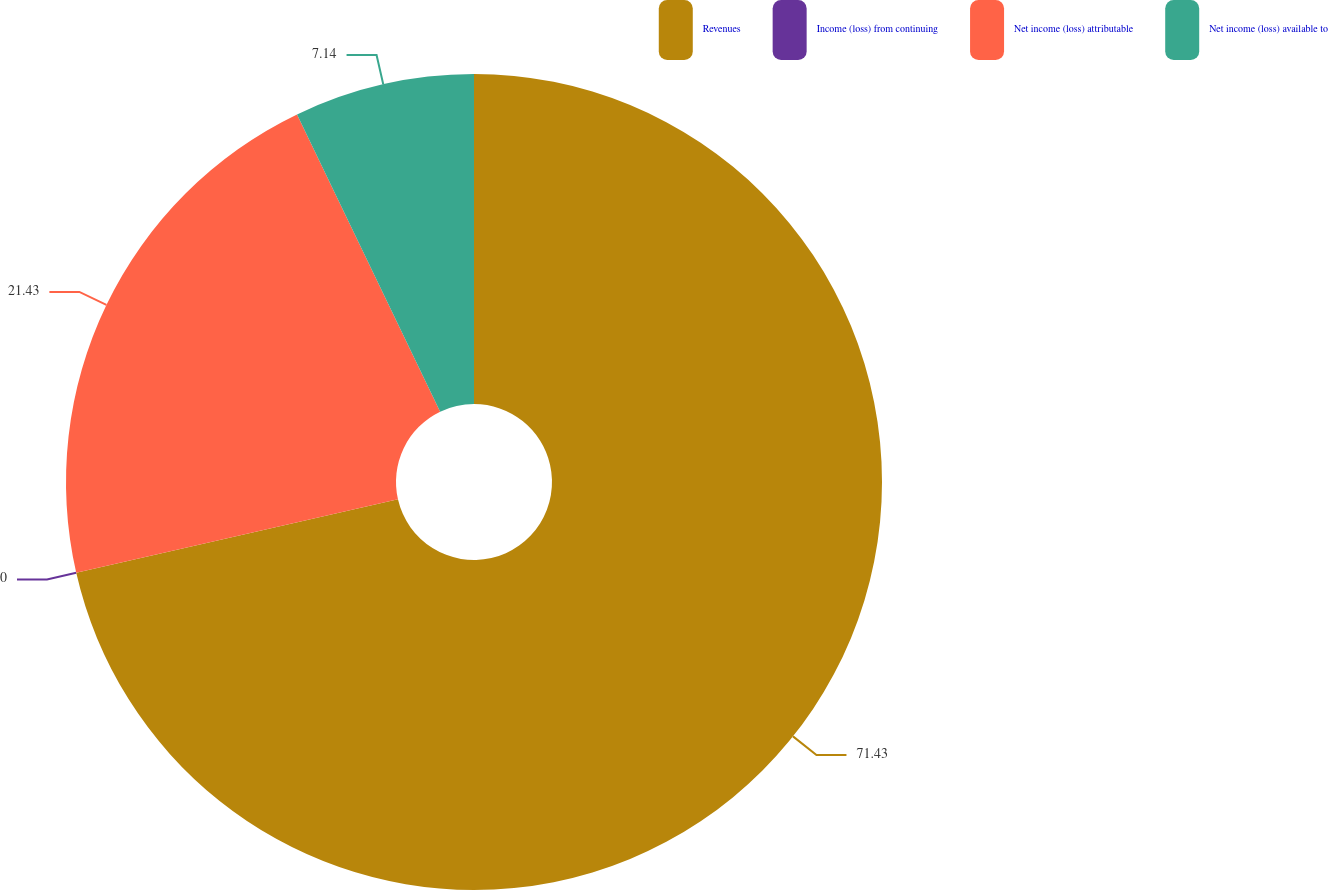<chart> <loc_0><loc_0><loc_500><loc_500><pie_chart><fcel>Revenues<fcel>Income (loss) from continuing<fcel>Net income (loss) attributable<fcel>Net income (loss) available to<nl><fcel>71.42%<fcel>0.0%<fcel>21.43%<fcel>7.14%<nl></chart> 